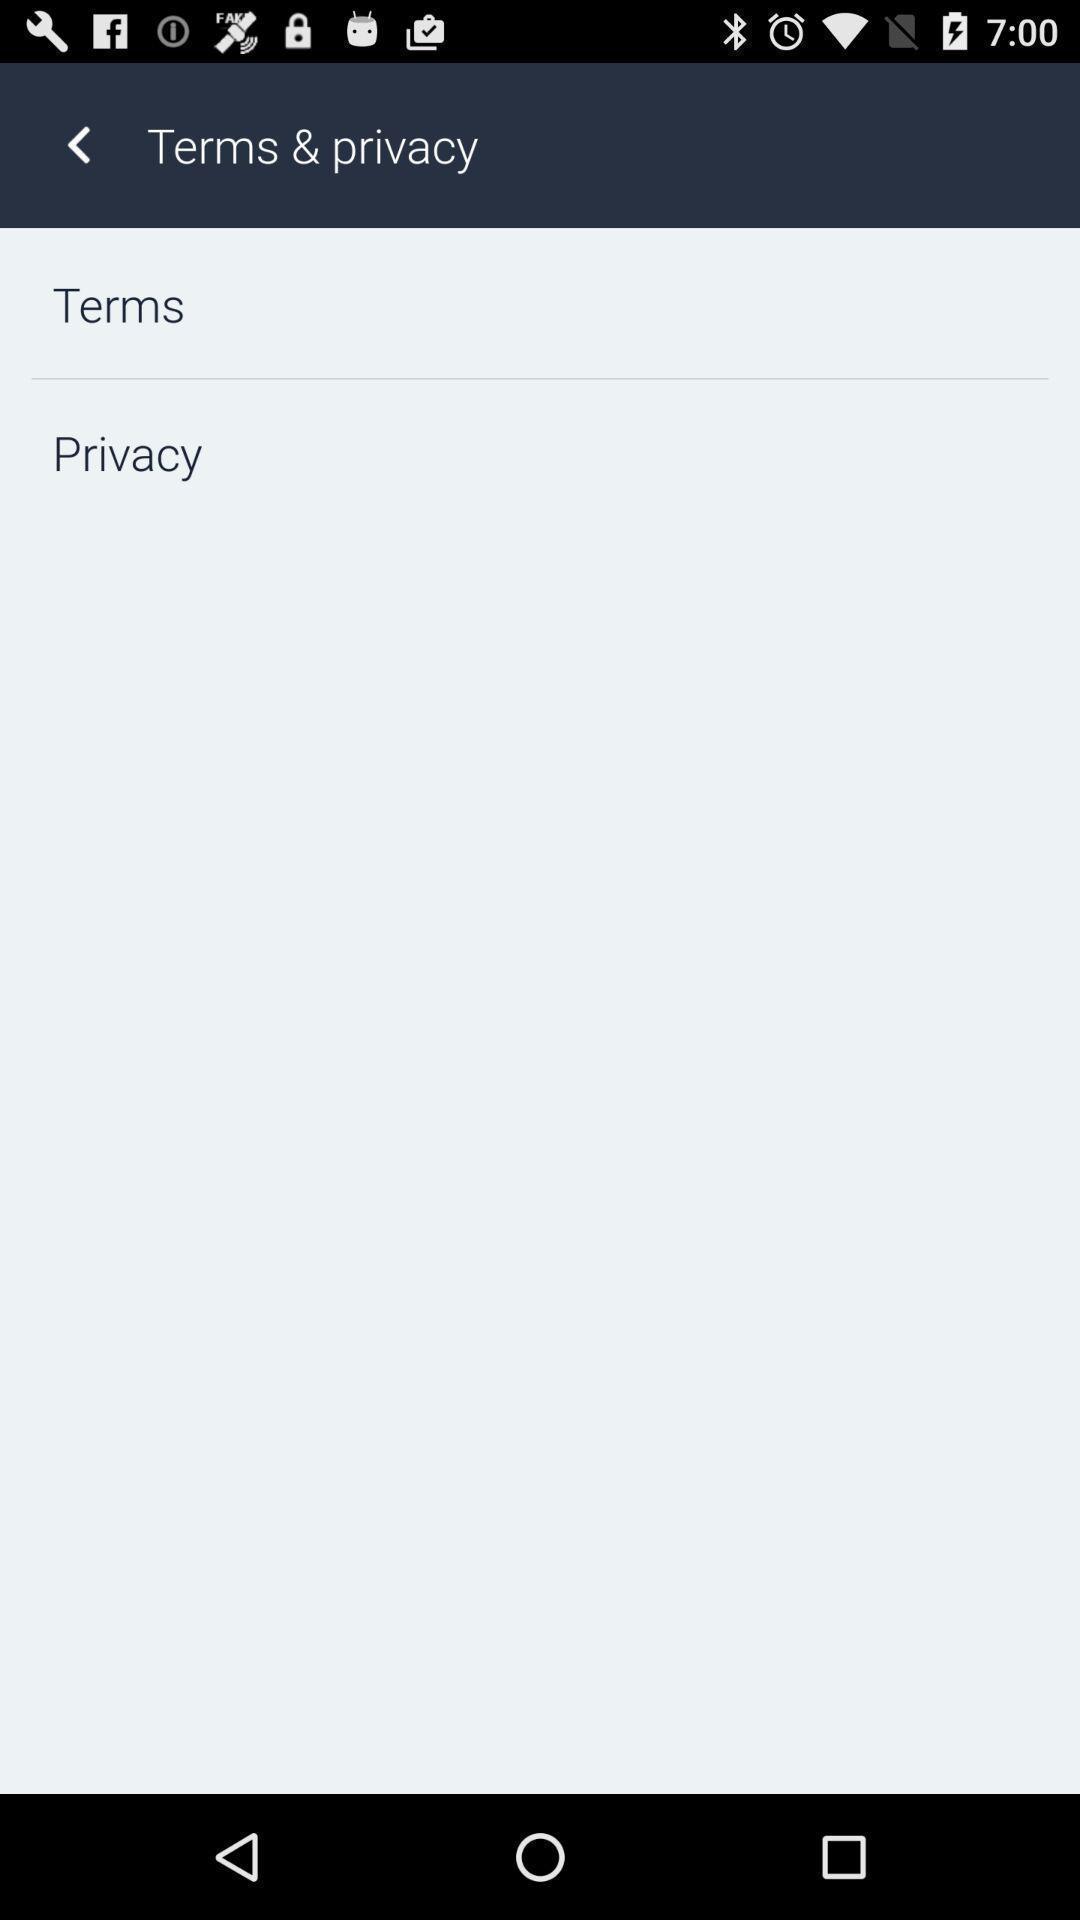Please provide a description for this image. Page showing terms and privacy options. 